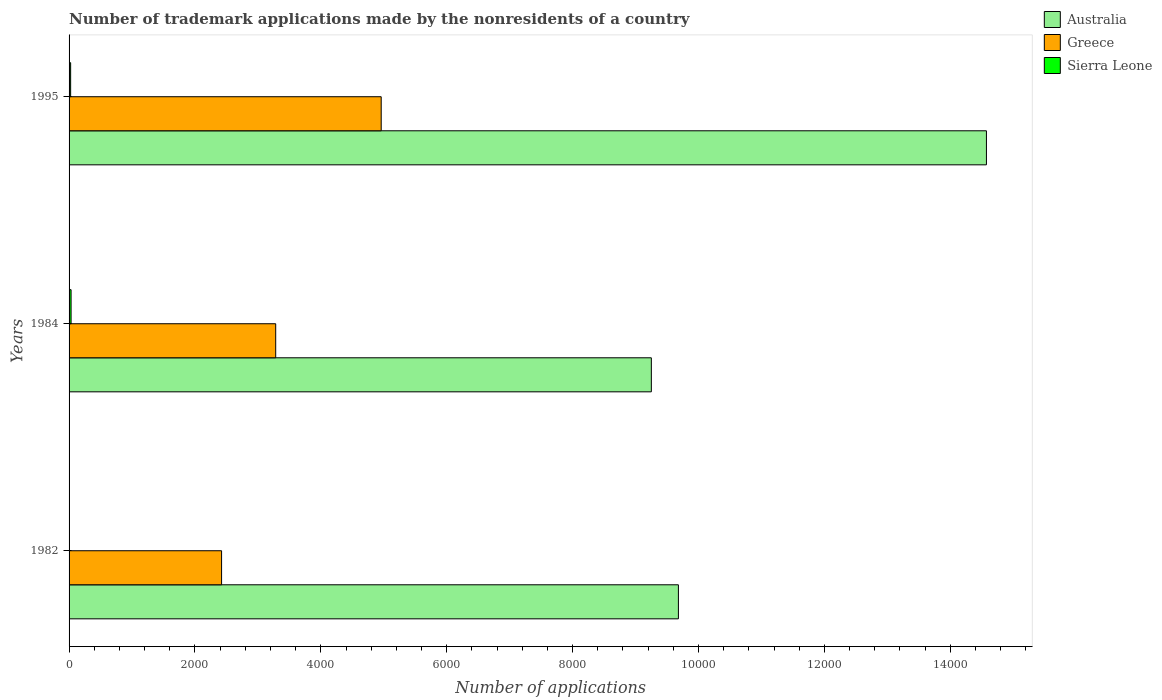How many different coloured bars are there?
Your answer should be very brief. 3. How many groups of bars are there?
Your response must be concise. 3. Are the number of bars per tick equal to the number of legend labels?
Keep it short and to the point. Yes. Are the number of bars on each tick of the Y-axis equal?
Provide a short and direct response. Yes. How many bars are there on the 2nd tick from the top?
Ensure brevity in your answer.  3. In how many cases, is the number of bars for a given year not equal to the number of legend labels?
Provide a short and direct response. 0. What is the number of trademark applications made by the nonresidents in Australia in 1982?
Your answer should be compact. 9681. Across all years, what is the maximum number of trademark applications made by the nonresidents in Australia?
Keep it short and to the point. 1.46e+04. Across all years, what is the minimum number of trademark applications made by the nonresidents in Greece?
Offer a very short reply. 2423. What is the total number of trademark applications made by the nonresidents in Australia in the graph?
Offer a terse response. 3.35e+04. What is the difference between the number of trademark applications made by the nonresidents in Greece in 1995 and the number of trademark applications made by the nonresidents in Australia in 1982?
Offer a terse response. -4722. What is the average number of trademark applications made by the nonresidents in Greece per year?
Make the answer very short. 3555. In the year 1984, what is the difference between the number of trademark applications made by the nonresidents in Greece and number of trademark applications made by the nonresidents in Australia?
Provide a short and direct response. -5968. What is the ratio of the number of trademark applications made by the nonresidents in Australia in 1982 to that in 1984?
Keep it short and to the point. 1.05. What is the difference between the highest and the second highest number of trademark applications made by the nonresidents in Greece?
Offer a terse response. 1676. What is the difference between the highest and the lowest number of trademark applications made by the nonresidents in Australia?
Your response must be concise. 5324. In how many years, is the number of trademark applications made by the nonresidents in Australia greater than the average number of trademark applications made by the nonresidents in Australia taken over all years?
Your answer should be compact. 1. What does the 1st bar from the top in 1984 represents?
Give a very brief answer. Sierra Leone. What does the 3rd bar from the bottom in 1982 represents?
Provide a short and direct response. Sierra Leone. Are the values on the major ticks of X-axis written in scientific E-notation?
Keep it short and to the point. No. Does the graph contain grids?
Give a very brief answer. No. Where does the legend appear in the graph?
Your answer should be compact. Top right. How are the legend labels stacked?
Your response must be concise. Vertical. What is the title of the graph?
Ensure brevity in your answer.  Number of trademark applications made by the nonresidents of a country. Does "Middle East & North Africa (all income levels)" appear as one of the legend labels in the graph?
Offer a very short reply. No. What is the label or title of the X-axis?
Your answer should be compact. Number of applications. What is the label or title of the Y-axis?
Provide a short and direct response. Years. What is the Number of applications in Australia in 1982?
Provide a short and direct response. 9681. What is the Number of applications in Greece in 1982?
Your response must be concise. 2423. What is the Number of applications of Sierra Leone in 1982?
Provide a short and direct response. 5. What is the Number of applications in Australia in 1984?
Your response must be concise. 9251. What is the Number of applications of Greece in 1984?
Offer a terse response. 3283. What is the Number of applications in Australia in 1995?
Give a very brief answer. 1.46e+04. What is the Number of applications of Greece in 1995?
Keep it short and to the point. 4959. Across all years, what is the maximum Number of applications in Australia?
Offer a terse response. 1.46e+04. Across all years, what is the maximum Number of applications of Greece?
Your response must be concise. 4959. Across all years, what is the maximum Number of applications in Sierra Leone?
Your answer should be very brief. 32. Across all years, what is the minimum Number of applications in Australia?
Make the answer very short. 9251. Across all years, what is the minimum Number of applications in Greece?
Your response must be concise. 2423. Across all years, what is the minimum Number of applications of Sierra Leone?
Give a very brief answer. 5. What is the total Number of applications of Australia in the graph?
Give a very brief answer. 3.35e+04. What is the total Number of applications of Greece in the graph?
Provide a short and direct response. 1.07e+04. What is the total Number of applications in Sierra Leone in the graph?
Keep it short and to the point. 62. What is the difference between the Number of applications in Australia in 1982 and that in 1984?
Your response must be concise. 430. What is the difference between the Number of applications of Greece in 1982 and that in 1984?
Your answer should be compact. -860. What is the difference between the Number of applications of Sierra Leone in 1982 and that in 1984?
Make the answer very short. -27. What is the difference between the Number of applications of Australia in 1982 and that in 1995?
Your answer should be compact. -4894. What is the difference between the Number of applications of Greece in 1982 and that in 1995?
Your answer should be compact. -2536. What is the difference between the Number of applications of Australia in 1984 and that in 1995?
Keep it short and to the point. -5324. What is the difference between the Number of applications in Greece in 1984 and that in 1995?
Provide a short and direct response. -1676. What is the difference between the Number of applications in Sierra Leone in 1984 and that in 1995?
Offer a very short reply. 7. What is the difference between the Number of applications in Australia in 1982 and the Number of applications in Greece in 1984?
Your answer should be very brief. 6398. What is the difference between the Number of applications of Australia in 1982 and the Number of applications of Sierra Leone in 1984?
Provide a short and direct response. 9649. What is the difference between the Number of applications in Greece in 1982 and the Number of applications in Sierra Leone in 1984?
Your answer should be compact. 2391. What is the difference between the Number of applications in Australia in 1982 and the Number of applications in Greece in 1995?
Give a very brief answer. 4722. What is the difference between the Number of applications of Australia in 1982 and the Number of applications of Sierra Leone in 1995?
Offer a terse response. 9656. What is the difference between the Number of applications in Greece in 1982 and the Number of applications in Sierra Leone in 1995?
Offer a terse response. 2398. What is the difference between the Number of applications of Australia in 1984 and the Number of applications of Greece in 1995?
Provide a short and direct response. 4292. What is the difference between the Number of applications in Australia in 1984 and the Number of applications in Sierra Leone in 1995?
Give a very brief answer. 9226. What is the difference between the Number of applications in Greece in 1984 and the Number of applications in Sierra Leone in 1995?
Your response must be concise. 3258. What is the average Number of applications in Australia per year?
Give a very brief answer. 1.12e+04. What is the average Number of applications of Greece per year?
Provide a succinct answer. 3555. What is the average Number of applications of Sierra Leone per year?
Your answer should be very brief. 20.67. In the year 1982, what is the difference between the Number of applications of Australia and Number of applications of Greece?
Provide a short and direct response. 7258. In the year 1982, what is the difference between the Number of applications of Australia and Number of applications of Sierra Leone?
Your answer should be compact. 9676. In the year 1982, what is the difference between the Number of applications of Greece and Number of applications of Sierra Leone?
Ensure brevity in your answer.  2418. In the year 1984, what is the difference between the Number of applications of Australia and Number of applications of Greece?
Keep it short and to the point. 5968. In the year 1984, what is the difference between the Number of applications of Australia and Number of applications of Sierra Leone?
Offer a terse response. 9219. In the year 1984, what is the difference between the Number of applications of Greece and Number of applications of Sierra Leone?
Make the answer very short. 3251. In the year 1995, what is the difference between the Number of applications in Australia and Number of applications in Greece?
Offer a terse response. 9616. In the year 1995, what is the difference between the Number of applications in Australia and Number of applications in Sierra Leone?
Offer a very short reply. 1.46e+04. In the year 1995, what is the difference between the Number of applications of Greece and Number of applications of Sierra Leone?
Offer a terse response. 4934. What is the ratio of the Number of applications in Australia in 1982 to that in 1984?
Provide a short and direct response. 1.05. What is the ratio of the Number of applications in Greece in 1982 to that in 1984?
Keep it short and to the point. 0.74. What is the ratio of the Number of applications of Sierra Leone in 1982 to that in 1984?
Your answer should be very brief. 0.16. What is the ratio of the Number of applications of Australia in 1982 to that in 1995?
Ensure brevity in your answer.  0.66. What is the ratio of the Number of applications of Greece in 1982 to that in 1995?
Give a very brief answer. 0.49. What is the ratio of the Number of applications of Sierra Leone in 1982 to that in 1995?
Offer a terse response. 0.2. What is the ratio of the Number of applications of Australia in 1984 to that in 1995?
Your answer should be compact. 0.63. What is the ratio of the Number of applications of Greece in 1984 to that in 1995?
Offer a terse response. 0.66. What is the ratio of the Number of applications in Sierra Leone in 1984 to that in 1995?
Your answer should be very brief. 1.28. What is the difference between the highest and the second highest Number of applications of Australia?
Your answer should be compact. 4894. What is the difference between the highest and the second highest Number of applications of Greece?
Keep it short and to the point. 1676. What is the difference between the highest and the second highest Number of applications of Sierra Leone?
Your response must be concise. 7. What is the difference between the highest and the lowest Number of applications in Australia?
Ensure brevity in your answer.  5324. What is the difference between the highest and the lowest Number of applications in Greece?
Provide a succinct answer. 2536. 